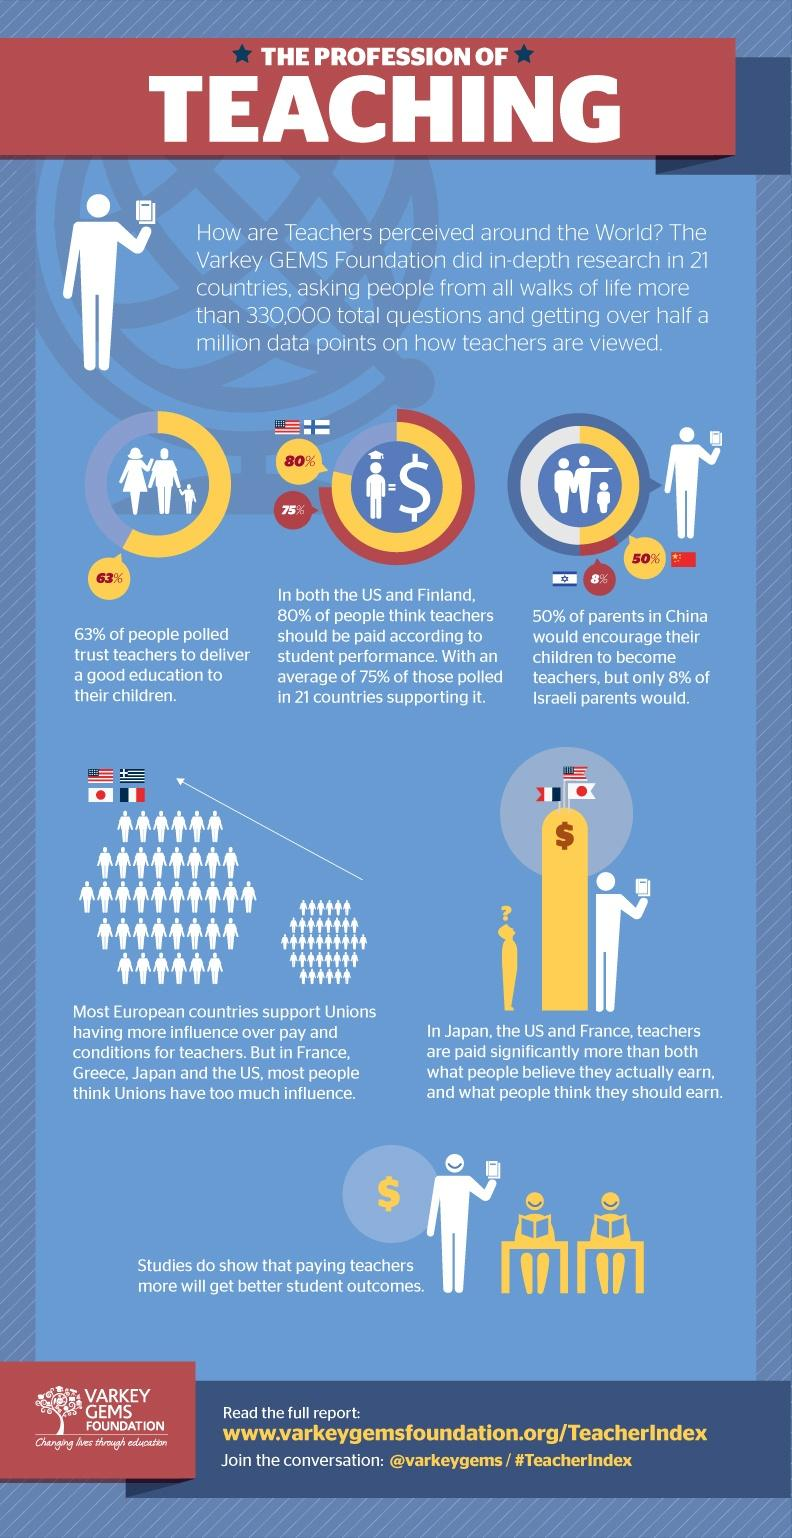Point out several critical features in this image. The report has mentioned Japan, China, and Israel, all of which are Asian countries. According to a poll, a significant percentage of people do not believe that teachers are capable of delivering a good education to their children. Specifically, 37% of those polled said that they do not trust teachers to provide a quality education. According to the provided information, it is clear that Chinese parents prefer their children to become teachers, while Israeli parents do not have a strong preference in this regard. The countries of Japan, the United States, and France are known for having highly paid teachers. 